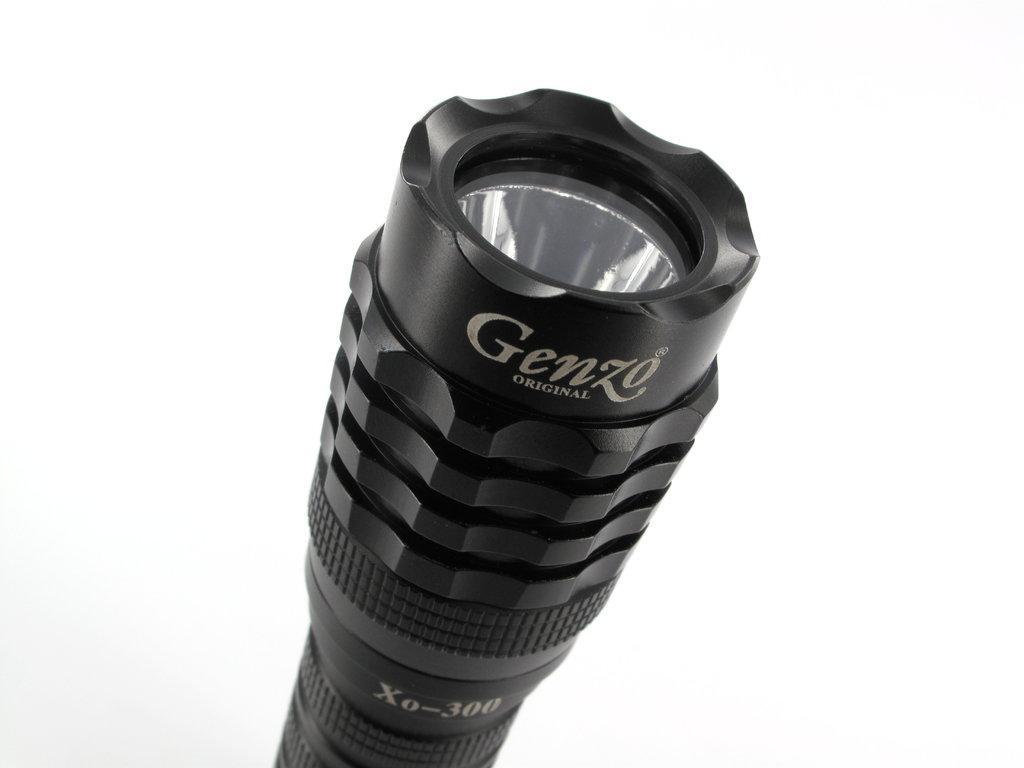Describe this image in one or two sentences. This picture contains a torch light. It is black in color. On top of it, it is written as "Genzo". In the background, it is white in color. 